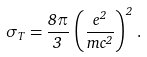<formula> <loc_0><loc_0><loc_500><loc_500>\sigma _ { T } = \frac { 8 \pi } { 3 } \, \left ( \frac { e ^ { 2 } } { m c ^ { 2 } } \right ) ^ { 2 } \, .</formula> 